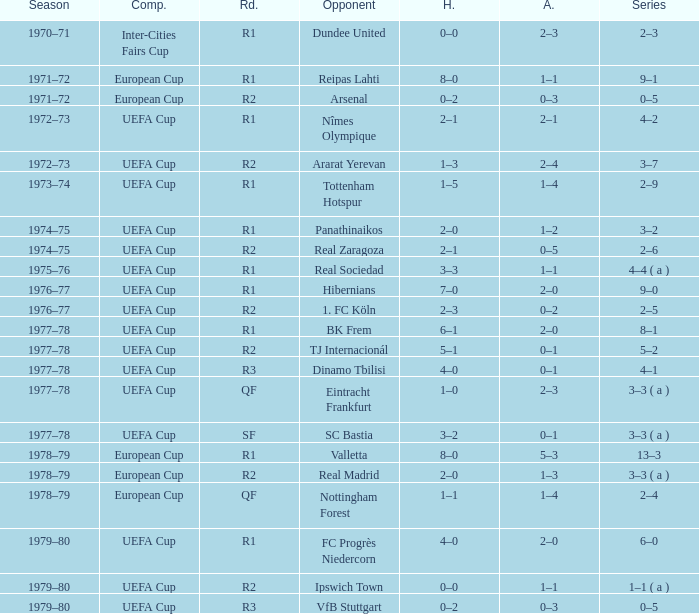Which Series has a Home of 2–0, and an Opponent of panathinaikos? 3–2. 